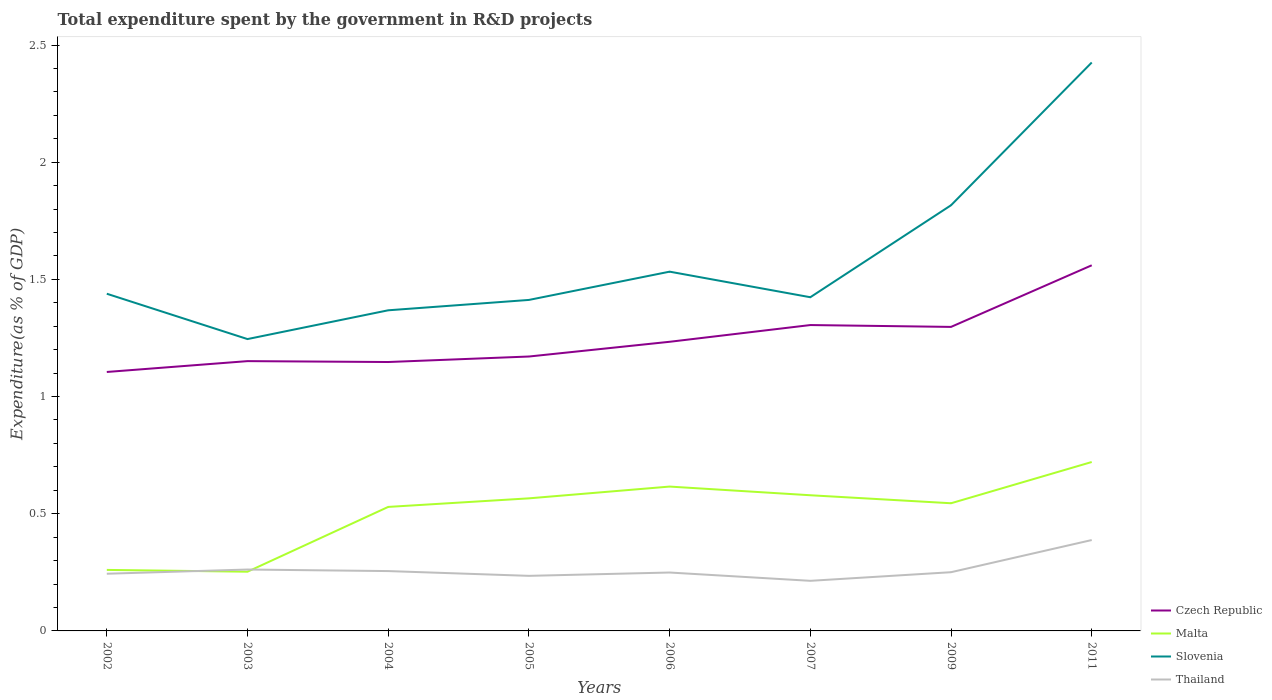How many different coloured lines are there?
Make the answer very short. 4. Does the line corresponding to Malta intersect with the line corresponding to Czech Republic?
Your response must be concise. No. Is the number of lines equal to the number of legend labels?
Your response must be concise. Yes. Across all years, what is the maximum total expenditure spent by the government in R&D projects in Czech Republic?
Provide a succinct answer. 1.1. In which year was the total expenditure spent by the government in R&D projects in Slovenia maximum?
Offer a very short reply. 2003. What is the total total expenditure spent by the government in R&D projects in Thailand in the graph?
Keep it short and to the point. -0.17. What is the difference between the highest and the second highest total expenditure spent by the government in R&D projects in Malta?
Keep it short and to the point. 0.47. Is the total expenditure spent by the government in R&D projects in Thailand strictly greater than the total expenditure spent by the government in R&D projects in Czech Republic over the years?
Your response must be concise. Yes. How many lines are there?
Ensure brevity in your answer.  4. What is the difference between two consecutive major ticks on the Y-axis?
Your answer should be very brief. 0.5. Are the values on the major ticks of Y-axis written in scientific E-notation?
Provide a succinct answer. No. How many legend labels are there?
Provide a short and direct response. 4. How are the legend labels stacked?
Offer a very short reply. Vertical. What is the title of the graph?
Your answer should be compact. Total expenditure spent by the government in R&D projects. What is the label or title of the Y-axis?
Your answer should be compact. Expenditure(as % of GDP). What is the Expenditure(as % of GDP) in Czech Republic in 2002?
Give a very brief answer. 1.1. What is the Expenditure(as % of GDP) in Malta in 2002?
Your answer should be very brief. 0.26. What is the Expenditure(as % of GDP) in Slovenia in 2002?
Provide a succinct answer. 1.44. What is the Expenditure(as % of GDP) of Thailand in 2002?
Offer a very short reply. 0.24. What is the Expenditure(as % of GDP) of Czech Republic in 2003?
Provide a succinct answer. 1.15. What is the Expenditure(as % of GDP) of Malta in 2003?
Provide a succinct answer. 0.25. What is the Expenditure(as % of GDP) in Slovenia in 2003?
Ensure brevity in your answer.  1.25. What is the Expenditure(as % of GDP) in Thailand in 2003?
Your answer should be compact. 0.26. What is the Expenditure(as % of GDP) of Czech Republic in 2004?
Offer a terse response. 1.15. What is the Expenditure(as % of GDP) of Malta in 2004?
Provide a short and direct response. 0.53. What is the Expenditure(as % of GDP) of Slovenia in 2004?
Give a very brief answer. 1.37. What is the Expenditure(as % of GDP) of Thailand in 2004?
Offer a terse response. 0.26. What is the Expenditure(as % of GDP) in Czech Republic in 2005?
Your answer should be compact. 1.17. What is the Expenditure(as % of GDP) in Malta in 2005?
Provide a short and direct response. 0.57. What is the Expenditure(as % of GDP) in Slovenia in 2005?
Keep it short and to the point. 1.41. What is the Expenditure(as % of GDP) in Thailand in 2005?
Your answer should be compact. 0.23. What is the Expenditure(as % of GDP) of Czech Republic in 2006?
Your answer should be very brief. 1.23. What is the Expenditure(as % of GDP) in Malta in 2006?
Keep it short and to the point. 0.62. What is the Expenditure(as % of GDP) of Slovenia in 2006?
Offer a very short reply. 1.53. What is the Expenditure(as % of GDP) in Thailand in 2006?
Offer a terse response. 0.25. What is the Expenditure(as % of GDP) in Czech Republic in 2007?
Make the answer very short. 1.31. What is the Expenditure(as % of GDP) of Malta in 2007?
Provide a short and direct response. 0.58. What is the Expenditure(as % of GDP) of Slovenia in 2007?
Give a very brief answer. 1.42. What is the Expenditure(as % of GDP) of Thailand in 2007?
Keep it short and to the point. 0.21. What is the Expenditure(as % of GDP) of Czech Republic in 2009?
Your answer should be very brief. 1.3. What is the Expenditure(as % of GDP) of Malta in 2009?
Your response must be concise. 0.54. What is the Expenditure(as % of GDP) in Slovenia in 2009?
Keep it short and to the point. 1.82. What is the Expenditure(as % of GDP) of Thailand in 2009?
Provide a short and direct response. 0.25. What is the Expenditure(as % of GDP) in Czech Republic in 2011?
Offer a terse response. 1.56. What is the Expenditure(as % of GDP) of Malta in 2011?
Provide a short and direct response. 0.72. What is the Expenditure(as % of GDP) in Slovenia in 2011?
Your answer should be compact. 2.43. What is the Expenditure(as % of GDP) in Thailand in 2011?
Ensure brevity in your answer.  0.39. Across all years, what is the maximum Expenditure(as % of GDP) of Czech Republic?
Your answer should be very brief. 1.56. Across all years, what is the maximum Expenditure(as % of GDP) in Malta?
Provide a succinct answer. 0.72. Across all years, what is the maximum Expenditure(as % of GDP) of Slovenia?
Your answer should be very brief. 2.43. Across all years, what is the maximum Expenditure(as % of GDP) in Thailand?
Your response must be concise. 0.39. Across all years, what is the minimum Expenditure(as % of GDP) of Czech Republic?
Your response must be concise. 1.1. Across all years, what is the minimum Expenditure(as % of GDP) in Malta?
Ensure brevity in your answer.  0.25. Across all years, what is the minimum Expenditure(as % of GDP) of Slovenia?
Make the answer very short. 1.25. Across all years, what is the minimum Expenditure(as % of GDP) of Thailand?
Keep it short and to the point. 0.21. What is the total Expenditure(as % of GDP) in Czech Republic in the graph?
Provide a short and direct response. 9.97. What is the total Expenditure(as % of GDP) in Malta in the graph?
Give a very brief answer. 4.07. What is the total Expenditure(as % of GDP) of Slovenia in the graph?
Provide a short and direct response. 12.66. What is the total Expenditure(as % of GDP) of Thailand in the graph?
Your answer should be very brief. 2.1. What is the difference between the Expenditure(as % of GDP) of Czech Republic in 2002 and that in 2003?
Offer a very short reply. -0.05. What is the difference between the Expenditure(as % of GDP) in Malta in 2002 and that in 2003?
Provide a succinct answer. 0.01. What is the difference between the Expenditure(as % of GDP) in Slovenia in 2002 and that in 2003?
Ensure brevity in your answer.  0.19. What is the difference between the Expenditure(as % of GDP) in Thailand in 2002 and that in 2003?
Your answer should be very brief. -0.02. What is the difference between the Expenditure(as % of GDP) in Czech Republic in 2002 and that in 2004?
Your response must be concise. -0.04. What is the difference between the Expenditure(as % of GDP) of Malta in 2002 and that in 2004?
Provide a short and direct response. -0.27. What is the difference between the Expenditure(as % of GDP) in Slovenia in 2002 and that in 2004?
Your answer should be compact. 0.07. What is the difference between the Expenditure(as % of GDP) of Thailand in 2002 and that in 2004?
Provide a short and direct response. -0.01. What is the difference between the Expenditure(as % of GDP) of Czech Republic in 2002 and that in 2005?
Offer a terse response. -0.07. What is the difference between the Expenditure(as % of GDP) of Malta in 2002 and that in 2005?
Make the answer very short. -0.31. What is the difference between the Expenditure(as % of GDP) of Slovenia in 2002 and that in 2005?
Your response must be concise. 0.03. What is the difference between the Expenditure(as % of GDP) of Thailand in 2002 and that in 2005?
Offer a very short reply. 0.01. What is the difference between the Expenditure(as % of GDP) of Czech Republic in 2002 and that in 2006?
Keep it short and to the point. -0.13. What is the difference between the Expenditure(as % of GDP) of Malta in 2002 and that in 2006?
Your response must be concise. -0.36. What is the difference between the Expenditure(as % of GDP) of Slovenia in 2002 and that in 2006?
Provide a short and direct response. -0.09. What is the difference between the Expenditure(as % of GDP) in Thailand in 2002 and that in 2006?
Your answer should be compact. -0.01. What is the difference between the Expenditure(as % of GDP) of Czech Republic in 2002 and that in 2007?
Give a very brief answer. -0.2. What is the difference between the Expenditure(as % of GDP) of Malta in 2002 and that in 2007?
Offer a very short reply. -0.32. What is the difference between the Expenditure(as % of GDP) of Slovenia in 2002 and that in 2007?
Make the answer very short. 0.01. What is the difference between the Expenditure(as % of GDP) in Thailand in 2002 and that in 2007?
Offer a terse response. 0.03. What is the difference between the Expenditure(as % of GDP) of Czech Republic in 2002 and that in 2009?
Your answer should be compact. -0.19. What is the difference between the Expenditure(as % of GDP) in Malta in 2002 and that in 2009?
Offer a terse response. -0.28. What is the difference between the Expenditure(as % of GDP) of Slovenia in 2002 and that in 2009?
Your answer should be compact. -0.38. What is the difference between the Expenditure(as % of GDP) of Thailand in 2002 and that in 2009?
Ensure brevity in your answer.  -0.01. What is the difference between the Expenditure(as % of GDP) of Czech Republic in 2002 and that in 2011?
Give a very brief answer. -0.46. What is the difference between the Expenditure(as % of GDP) in Malta in 2002 and that in 2011?
Your answer should be compact. -0.46. What is the difference between the Expenditure(as % of GDP) of Slovenia in 2002 and that in 2011?
Give a very brief answer. -0.99. What is the difference between the Expenditure(as % of GDP) of Thailand in 2002 and that in 2011?
Give a very brief answer. -0.14. What is the difference between the Expenditure(as % of GDP) in Czech Republic in 2003 and that in 2004?
Offer a terse response. 0. What is the difference between the Expenditure(as % of GDP) in Malta in 2003 and that in 2004?
Your answer should be compact. -0.28. What is the difference between the Expenditure(as % of GDP) in Slovenia in 2003 and that in 2004?
Keep it short and to the point. -0.12. What is the difference between the Expenditure(as % of GDP) in Thailand in 2003 and that in 2004?
Provide a succinct answer. 0.01. What is the difference between the Expenditure(as % of GDP) in Czech Republic in 2003 and that in 2005?
Your answer should be compact. -0.02. What is the difference between the Expenditure(as % of GDP) of Malta in 2003 and that in 2005?
Offer a terse response. -0.31. What is the difference between the Expenditure(as % of GDP) in Slovenia in 2003 and that in 2005?
Your answer should be compact. -0.17. What is the difference between the Expenditure(as % of GDP) in Thailand in 2003 and that in 2005?
Offer a very short reply. 0.03. What is the difference between the Expenditure(as % of GDP) of Czech Republic in 2003 and that in 2006?
Provide a succinct answer. -0.08. What is the difference between the Expenditure(as % of GDP) of Malta in 2003 and that in 2006?
Your response must be concise. -0.36. What is the difference between the Expenditure(as % of GDP) in Slovenia in 2003 and that in 2006?
Provide a succinct answer. -0.29. What is the difference between the Expenditure(as % of GDP) of Thailand in 2003 and that in 2006?
Your answer should be very brief. 0.01. What is the difference between the Expenditure(as % of GDP) in Czech Republic in 2003 and that in 2007?
Keep it short and to the point. -0.15. What is the difference between the Expenditure(as % of GDP) in Malta in 2003 and that in 2007?
Make the answer very short. -0.33. What is the difference between the Expenditure(as % of GDP) of Slovenia in 2003 and that in 2007?
Ensure brevity in your answer.  -0.18. What is the difference between the Expenditure(as % of GDP) of Thailand in 2003 and that in 2007?
Keep it short and to the point. 0.05. What is the difference between the Expenditure(as % of GDP) in Czech Republic in 2003 and that in 2009?
Offer a very short reply. -0.15. What is the difference between the Expenditure(as % of GDP) in Malta in 2003 and that in 2009?
Keep it short and to the point. -0.29. What is the difference between the Expenditure(as % of GDP) of Slovenia in 2003 and that in 2009?
Provide a succinct answer. -0.57. What is the difference between the Expenditure(as % of GDP) of Thailand in 2003 and that in 2009?
Your response must be concise. 0.01. What is the difference between the Expenditure(as % of GDP) of Czech Republic in 2003 and that in 2011?
Offer a terse response. -0.41. What is the difference between the Expenditure(as % of GDP) of Malta in 2003 and that in 2011?
Offer a very short reply. -0.47. What is the difference between the Expenditure(as % of GDP) of Slovenia in 2003 and that in 2011?
Ensure brevity in your answer.  -1.18. What is the difference between the Expenditure(as % of GDP) of Thailand in 2003 and that in 2011?
Your response must be concise. -0.13. What is the difference between the Expenditure(as % of GDP) of Czech Republic in 2004 and that in 2005?
Keep it short and to the point. -0.02. What is the difference between the Expenditure(as % of GDP) of Malta in 2004 and that in 2005?
Offer a terse response. -0.04. What is the difference between the Expenditure(as % of GDP) of Slovenia in 2004 and that in 2005?
Your answer should be compact. -0.04. What is the difference between the Expenditure(as % of GDP) in Thailand in 2004 and that in 2005?
Give a very brief answer. 0.02. What is the difference between the Expenditure(as % of GDP) of Czech Republic in 2004 and that in 2006?
Offer a terse response. -0.09. What is the difference between the Expenditure(as % of GDP) in Malta in 2004 and that in 2006?
Your answer should be compact. -0.09. What is the difference between the Expenditure(as % of GDP) in Slovenia in 2004 and that in 2006?
Offer a very short reply. -0.16. What is the difference between the Expenditure(as % of GDP) in Thailand in 2004 and that in 2006?
Your response must be concise. 0.01. What is the difference between the Expenditure(as % of GDP) in Czech Republic in 2004 and that in 2007?
Keep it short and to the point. -0.16. What is the difference between the Expenditure(as % of GDP) of Malta in 2004 and that in 2007?
Keep it short and to the point. -0.05. What is the difference between the Expenditure(as % of GDP) in Slovenia in 2004 and that in 2007?
Give a very brief answer. -0.06. What is the difference between the Expenditure(as % of GDP) in Thailand in 2004 and that in 2007?
Make the answer very short. 0.04. What is the difference between the Expenditure(as % of GDP) of Czech Republic in 2004 and that in 2009?
Give a very brief answer. -0.15. What is the difference between the Expenditure(as % of GDP) of Malta in 2004 and that in 2009?
Your answer should be compact. -0.02. What is the difference between the Expenditure(as % of GDP) in Slovenia in 2004 and that in 2009?
Give a very brief answer. -0.45. What is the difference between the Expenditure(as % of GDP) of Thailand in 2004 and that in 2009?
Keep it short and to the point. 0. What is the difference between the Expenditure(as % of GDP) of Czech Republic in 2004 and that in 2011?
Keep it short and to the point. -0.41. What is the difference between the Expenditure(as % of GDP) of Malta in 2004 and that in 2011?
Offer a terse response. -0.19. What is the difference between the Expenditure(as % of GDP) in Slovenia in 2004 and that in 2011?
Your answer should be compact. -1.06. What is the difference between the Expenditure(as % of GDP) of Thailand in 2004 and that in 2011?
Your answer should be very brief. -0.13. What is the difference between the Expenditure(as % of GDP) of Czech Republic in 2005 and that in 2006?
Make the answer very short. -0.06. What is the difference between the Expenditure(as % of GDP) in Malta in 2005 and that in 2006?
Your answer should be very brief. -0.05. What is the difference between the Expenditure(as % of GDP) in Slovenia in 2005 and that in 2006?
Your answer should be very brief. -0.12. What is the difference between the Expenditure(as % of GDP) in Thailand in 2005 and that in 2006?
Ensure brevity in your answer.  -0.01. What is the difference between the Expenditure(as % of GDP) of Czech Republic in 2005 and that in 2007?
Provide a short and direct response. -0.13. What is the difference between the Expenditure(as % of GDP) of Malta in 2005 and that in 2007?
Your response must be concise. -0.01. What is the difference between the Expenditure(as % of GDP) in Slovenia in 2005 and that in 2007?
Ensure brevity in your answer.  -0.01. What is the difference between the Expenditure(as % of GDP) in Thailand in 2005 and that in 2007?
Your answer should be compact. 0.02. What is the difference between the Expenditure(as % of GDP) of Czech Republic in 2005 and that in 2009?
Keep it short and to the point. -0.13. What is the difference between the Expenditure(as % of GDP) of Malta in 2005 and that in 2009?
Provide a succinct answer. 0.02. What is the difference between the Expenditure(as % of GDP) of Slovenia in 2005 and that in 2009?
Provide a short and direct response. -0.4. What is the difference between the Expenditure(as % of GDP) in Thailand in 2005 and that in 2009?
Your answer should be compact. -0.02. What is the difference between the Expenditure(as % of GDP) of Czech Republic in 2005 and that in 2011?
Ensure brevity in your answer.  -0.39. What is the difference between the Expenditure(as % of GDP) in Malta in 2005 and that in 2011?
Make the answer very short. -0.16. What is the difference between the Expenditure(as % of GDP) of Slovenia in 2005 and that in 2011?
Ensure brevity in your answer.  -1.01. What is the difference between the Expenditure(as % of GDP) in Thailand in 2005 and that in 2011?
Your answer should be compact. -0.15. What is the difference between the Expenditure(as % of GDP) in Czech Republic in 2006 and that in 2007?
Your answer should be compact. -0.07. What is the difference between the Expenditure(as % of GDP) of Malta in 2006 and that in 2007?
Your answer should be very brief. 0.04. What is the difference between the Expenditure(as % of GDP) in Slovenia in 2006 and that in 2007?
Your response must be concise. 0.11. What is the difference between the Expenditure(as % of GDP) in Thailand in 2006 and that in 2007?
Ensure brevity in your answer.  0.04. What is the difference between the Expenditure(as % of GDP) in Czech Republic in 2006 and that in 2009?
Your answer should be very brief. -0.06. What is the difference between the Expenditure(as % of GDP) of Malta in 2006 and that in 2009?
Your response must be concise. 0.07. What is the difference between the Expenditure(as % of GDP) in Slovenia in 2006 and that in 2009?
Your answer should be very brief. -0.28. What is the difference between the Expenditure(as % of GDP) of Thailand in 2006 and that in 2009?
Your answer should be compact. -0. What is the difference between the Expenditure(as % of GDP) in Czech Republic in 2006 and that in 2011?
Offer a very short reply. -0.33. What is the difference between the Expenditure(as % of GDP) of Malta in 2006 and that in 2011?
Your response must be concise. -0.1. What is the difference between the Expenditure(as % of GDP) in Slovenia in 2006 and that in 2011?
Give a very brief answer. -0.89. What is the difference between the Expenditure(as % of GDP) in Thailand in 2006 and that in 2011?
Your response must be concise. -0.14. What is the difference between the Expenditure(as % of GDP) of Czech Republic in 2007 and that in 2009?
Make the answer very short. 0.01. What is the difference between the Expenditure(as % of GDP) of Malta in 2007 and that in 2009?
Ensure brevity in your answer.  0.03. What is the difference between the Expenditure(as % of GDP) of Slovenia in 2007 and that in 2009?
Offer a terse response. -0.39. What is the difference between the Expenditure(as % of GDP) in Thailand in 2007 and that in 2009?
Your answer should be very brief. -0.04. What is the difference between the Expenditure(as % of GDP) of Czech Republic in 2007 and that in 2011?
Your answer should be compact. -0.26. What is the difference between the Expenditure(as % of GDP) of Malta in 2007 and that in 2011?
Ensure brevity in your answer.  -0.14. What is the difference between the Expenditure(as % of GDP) of Slovenia in 2007 and that in 2011?
Your answer should be very brief. -1. What is the difference between the Expenditure(as % of GDP) of Thailand in 2007 and that in 2011?
Ensure brevity in your answer.  -0.17. What is the difference between the Expenditure(as % of GDP) of Czech Republic in 2009 and that in 2011?
Provide a short and direct response. -0.26. What is the difference between the Expenditure(as % of GDP) in Malta in 2009 and that in 2011?
Your response must be concise. -0.18. What is the difference between the Expenditure(as % of GDP) of Slovenia in 2009 and that in 2011?
Keep it short and to the point. -0.61. What is the difference between the Expenditure(as % of GDP) of Thailand in 2009 and that in 2011?
Ensure brevity in your answer.  -0.14. What is the difference between the Expenditure(as % of GDP) in Czech Republic in 2002 and the Expenditure(as % of GDP) in Malta in 2003?
Your response must be concise. 0.85. What is the difference between the Expenditure(as % of GDP) in Czech Republic in 2002 and the Expenditure(as % of GDP) in Slovenia in 2003?
Offer a terse response. -0.14. What is the difference between the Expenditure(as % of GDP) of Czech Republic in 2002 and the Expenditure(as % of GDP) of Thailand in 2003?
Provide a short and direct response. 0.84. What is the difference between the Expenditure(as % of GDP) in Malta in 2002 and the Expenditure(as % of GDP) in Slovenia in 2003?
Make the answer very short. -0.98. What is the difference between the Expenditure(as % of GDP) in Malta in 2002 and the Expenditure(as % of GDP) in Thailand in 2003?
Offer a very short reply. -0. What is the difference between the Expenditure(as % of GDP) of Slovenia in 2002 and the Expenditure(as % of GDP) of Thailand in 2003?
Your answer should be very brief. 1.18. What is the difference between the Expenditure(as % of GDP) of Czech Republic in 2002 and the Expenditure(as % of GDP) of Malta in 2004?
Provide a short and direct response. 0.58. What is the difference between the Expenditure(as % of GDP) in Czech Republic in 2002 and the Expenditure(as % of GDP) in Slovenia in 2004?
Your answer should be compact. -0.26. What is the difference between the Expenditure(as % of GDP) in Czech Republic in 2002 and the Expenditure(as % of GDP) in Thailand in 2004?
Your answer should be compact. 0.85. What is the difference between the Expenditure(as % of GDP) in Malta in 2002 and the Expenditure(as % of GDP) in Slovenia in 2004?
Offer a terse response. -1.11. What is the difference between the Expenditure(as % of GDP) of Malta in 2002 and the Expenditure(as % of GDP) of Thailand in 2004?
Provide a succinct answer. 0.01. What is the difference between the Expenditure(as % of GDP) in Slovenia in 2002 and the Expenditure(as % of GDP) in Thailand in 2004?
Provide a short and direct response. 1.18. What is the difference between the Expenditure(as % of GDP) in Czech Republic in 2002 and the Expenditure(as % of GDP) in Malta in 2005?
Your answer should be compact. 0.54. What is the difference between the Expenditure(as % of GDP) in Czech Republic in 2002 and the Expenditure(as % of GDP) in Slovenia in 2005?
Offer a very short reply. -0.31. What is the difference between the Expenditure(as % of GDP) in Czech Republic in 2002 and the Expenditure(as % of GDP) in Thailand in 2005?
Provide a short and direct response. 0.87. What is the difference between the Expenditure(as % of GDP) of Malta in 2002 and the Expenditure(as % of GDP) of Slovenia in 2005?
Give a very brief answer. -1.15. What is the difference between the Expenditure(as % of GDP) of Malta in 2002 and the Expenditure(as % of GDP) of Thailand in 2005?
Make the answer very short. 0.03. What is the difference between the Expenditure(as % of GDP) of Slovenia in 2002 and the Expenditure(as % of GDP) of Thailand in 2005?
Your answer should be very brief. 1.2. What is the difference between the Expenditure(as % of GDP) of Czech Republic in 2002 and the Expenditure(as % of GDP) of Malta in 2006?
Offer a terse response. 0.49. What is the difference between the Expenditure(as % of GDP) of Czech Republic in 2002 and the Expenditure(as % of GDP) of Slovenia in 2006?
Your answer should be compact. -0.43. What is the difference between the Expenditure(as % of GDP) in Czech Republic in 2002 and the Expenditure(as % of GDP) in Thailand in 2006?
Make the answer very short. 0.86. What is the difference between the Expenditure(as % of GDP) in Malta in 2002 and the Expenditure(as % of GDP) in Slovenia in 2006?
Provide a short and direct response. -1.27. What is the difference between the Expenditure(as % of GDP) in Malta in 2002 and the Expenditure(as % of GDP) in Thailand in 2006?
Make the answer very short. 0.01. What is the difference between the Expenditure(as % of GDP) of Slovenia in 2002 and the Expenditure(as % of GDP) of Thailand in 2006?
Your response must be concise. 1.19. What is the difference between the Expenditure(as % of GDP) of Czech Republic in 2002 and the Expenditure(as % of GDP) of Malta in 2007?
Your response must be concise. 0.53. What is the difference between the Expenditure(as % of GDP) of Czech Republic in 2002 and the Expenditure(as % of GDP) of Slovenia in 2007?
Offer a terse response. -0.32. What is the difference between the Expenditure(as % of GDP) of Czech Republic in 2002 and the Expenditure(as % of GDP) of Thailand in 2007?
Keep it short and to the point. 0.89. What is the difference between the Expenditure(as % of GDP) of Malta in 2002 and the Expenditure(as % of GDP) of Slovenia in 2007?
Ensure brevity in your answer.  -1.16. What is the difference between the Expenditure(as % of GDP) of Malta in 2002 and the Expenditure(as % of GDP) of Thailand in 2007?
Your answer should be very brief. 0.05. What is the difference between the Expenditure(as % of GDP) in Slovenia in 2002 and the Expenditure(as % of GDP) in Thailand in 2007?
Ensure brevity in your answer.  1.23. What is the difference between the Expenditure(as % of GDP) in Czech Republic in 2002 and the Expenditure(as % of GDP) in Malta in 2009?
Offer a terse response. 0.56. What is the difference between the Expenditure(as % of GDP) in Czech Republic in 2002 and the Expenditure(as % of GDP) in Slovenia in 2009?
Your response must be concise. -0.71. What is the difference between the Expenditure(as % of GDP) in Czech Republic in 2002 and the Expenditure(as % of GDP) in Thailand in 2009?
Keep it short and to the point. 0.85. What is the difference between the Expenditure(as % of GDP) in Malta in 2002 and the Expenditure(as % of GDP) in Slovenia in 2009?
Ensure brevity in your answer.  -1.56. What is the difference between the Expenditure(as % of GDP) of Malta in 2002 and the Expenditure(as % of GDP) of Thailand in 2009?
Your response must be concise. 0.01. What is the difference between the Expenditure(as % of GDP) of Slovenia in 2002 and the Expenditure(as % of GDP) of Thailand in 2009?
Make the answer very short. 1.19. What is the difference between the Expenditure(as % of GDP) of Czech Republic in 2002 and the Expenditure(as % of GDP) of Malta in 2011?
Keep it short and to the point. 0.38. What is the difference between the Expenditure(as % of GDP) in Czech Republic in 2002 and the Expenditure(as % of GDP) in Slovenia in 2011?
Your answer should be compact. -1.32. What is the difference between the Expenditure(as % of GDP) of Czech Republic in 2002 and the Expenditure(as % of GDP) of Thailand in 2011?
Your answer should be compact. 0.72. What is the difference between the Expenditure(as % of GDP) in Malta in 2002 and the Expenditure(as % of GDP) in Slovenia in 2011?
Your answer should be compact. -2.17. What is the difference between the Expenditure(as % of GDP) in Malta in 2002 and the Expenditure(as % of GDP) in Thailand in 2011?
Provide a succinct answer. -0.13. What is the difference between the Expenditure(as % of GDP) of Slovenia in 2002 and the Expenditure(as % of GDP) of Thailand in 2011?
Make the answer very short. 1.05. What is the difference between the Expenditure(as % of GDP) in Czech Republic in 2003 and the Expenditure(as % of GDP) in Malta in 2004?
Provide a short and direct response. 0.62. What is the difference between the Expenditure(as % of GDP) of Czech Republic in 2003 and the Expenditure(as % of GDP) of Slovenia in 2004?
Your answer should be compact. -0.22. What is the difference between the Expenditure(as % of GDP) of Czech Republic in 2003 and the Expenditure(as % of GDP) of Thailand in 2004?
Ensure brevity in your answer.  0.9. What is the difference between the Expenditure(as % of GDP) in Malta in 2003 and the Expenditure(as % of GDP) in Slovenia in 2004?
Offer a very short reply. -1.12. What is the difference between the Expenditure(as % of GDP) of Malta in 2003 and the Expenditure(as % of GDP) of Thailand in 2004?
Your answer should be very brief. -0. What is the difference between the Expenditure(as % of GDP) of Slovenia in 2003 and the Expenditure(as % of GDP) of Thailand in 2004?
Make the answer very short. 0.99. What is the difference between the Expenditure(as % of GDP) in Czech Republic in 2003 and the Expenditure(as % of GDP) in Malta in 2005?
Provide a short and direct response. 0.59. What is the difference between the Expenditure(as % of GDP) in Czech Republic in 2003 and the Expenditure(as % of GDP) in Slovenia in 2005?
Offer a terse response. -0.26. What is the difference between the Expenditure(as % of GDP) in Czech Republic in 2003 and the Expenditure(as % of GDP) in Thailand in 2005?
Offer a terse response. 0.92. What is the difference between the Expenditure(as % of GDP) in Malta in 2003 and the Expenditure(as % of GDP) in Slovenia in 2005?
Your answer should be very brief. -1.16. What is the difference between the Expenditure(as % of GDP) of Malta in 2003 and the Expenditure(as % of GDP) of Thailand in 2005?
Your answer should be compact. 0.02. What is the difference between the Expenditure(as % of GDP) of Slovenia in 2003 and the Expenditure(as % of GDP) of Thailand in 2005?
Keep it short and to the point. 1.01. What is the difference between the Expenditure(as % of GDP) in Czech Republic in 2003 and the Expenditure(as % of GDP) in Malta in 2006?
Your answer should be compact. 0.54. What is the difference between the Expenditure(as % of GDP) in Czech Republic in 2003 and the Expenditure(as % of GDP) in Slovenia in 2006?
Provide a short and direct response. -0.38. What is the difference between the Expenditure(as % of GDP) in Czech Republic in 2003 and the Expenditure(as % of GDP) in Thailand in 2006?
Your response must be concise. 0.9. What is the difference between the Expenditure(as % of GDP) of Malta in 2003 and the Expenditure(as % of GDP) of Slovenia in 2006?
Make the answer very short. -1.28. What is the difference between the Expenditure(as % of GDP) of Malta in 2003 and the Expenditure(as % of GDP) of Thailand in 2006?
Provide a short and direct response. 0. What is the difference between the Expenditure(as % of GDP) of Czech Republic in 2003 and the Expenditure(as % of GDP) of Malta in 2007?
Provide a succinct answer. 0.57. What is the difference between the Expenditure(as % of GDP) of Czech Republic in 2003 and the Expenditure(as % of GDP) of Slovenia in 2007?
Your answer should be compact. -0.27. What is the difference between the Expenditure(as % of GDP) in Czech Republic in 2003 and the Expenditure(as % of GDP) in Thailand in 2007?
Offer a terse response. 0.94. What is the difference between the Expenditure(as % of GDP) in Malta in 2003 and the Expenditure(as % of GDP) in Slovenia in 2007?
Keep it short and to the point. -1.17. What is the difference between the Expenditure(as % of GDP) in Malta in 2003 and the Expenditure(as % of GDP) in Thailand in 2007?
Your answer should be very brief. 0.04. What is the difference between the Expenditure(as % of GDP) in Slovenia in 2003 and the Expenditure(as % of GDP) in Thailand in 2007?
Your response must be concise. 1.03. What is the difference between the Expenditure(as % of GDP) in Czech Republic in 2003 and the Expenditure(as % of GDP) in Malta in 2009?
Your answer should be compact. 0.61. What is the difference between the Expenditure(as % of GDP) of Czech Republic in 2003 and the Expenditure(as % of GDP) of Slovenia in 2009?
Ensure brevity in your answer.  -0.67. What is the difference between the Expenditure(as % of GDP) in Czech Republic in 2003 and the Expenditure(as % of GDP) in Thailand in 2009?
Your answer should be compact. 0.9. What is the difference between the Expenditure(as % of GDP) in Malta in 2003 and the Expenditure(as % of GDP) in Slovenia in 2009?
Give a very brief answer. -1.56. What is the difference between the Expenditure(as % of GDP) in Malta in 2003 and the Expenditure(as % of GDP) in Thailand in 2009?
Provide a succinct answer. 0. What is the difference between the Expenditure(as % of GDP) in Slovenia in 2003 and the Expenditure(as % of GDP) in Thailand in 2009?
Keep it short and to the point. 0.99. What is the difference between the Expenditure(as % of GDP) of Czech Republic in 2003 and the Expenditure(as % of GDP) of Malta in 2011?
Provide a short and direct response. 0.43. What is the difference between the Expenditure(as % of GDP) in Czech Republic in 2003 and the Expenditure(as % of GDP) in Slovenia in 2011?
Provide a succinct answer. -1.27. What is the difference between the Expenditure(as % of GDP) of Czech Republic in 2003 and the Expenditure(as % of GDP) of Thailand in 2011?
Your answer should be very brief. 0.76. What is the difference between the Expenditure(as % of GDP) in Malta in 2003 and the Expenditure(as % of GDP) in Slovenia in 2011?
Offer a very short reply. -2.17. What is the difference between the Expenditure(as % of GDP) in Malta in 2003 and the Expenditure(as % of GDP) in Thailand in 2011?
Your response must be concise. -0.14. What is the difference between the Expenditure(as % of GDP) of Slovenia in 2003 and the Expenditure(as % of GDP) of Thailand in 2011?
Your response must be concise. 0.86. What is the difference between the Expenditure(as % of GDP) of Czech Republic in 2004 and the Expenditure(as % of GDP) of Malta in 2005?
Provide a short and direct response. 0.58. What is the difference between the Expenditure(as % of GDP) of Czech Republic in 2004 and the Expenditure(as % of GDP) of Slovenia in 2005?
Your response must be concise. -0.26. What is the difference between the Expenditure(as % of GDP) in Czech Republic in 2004 and the Expenditure(as % of GDP) in Thailand in 2005?
Keep it short and to the point. 0.91. What is the difference between the Expenditure(as % of GDP) of Malta in 2004 and the Expenditure(as % of GDP) of Slovenia in 2005?
Your answer should be compact. -0.88. What is the difference between the Expenditure(as % of GDP) in Malta in 2004 and the Expenditure(as % of GDP) in Thailand in 2005?
Keep it short and to the point. 0.29. What is the difference between the Expenditure(as % of GDP) of Slovenia in 2004 and the Expenditure(as % of GDP) of Thailand in 2005?
Keep it short and to the point. 1.13. What is the difference between the Expenditure(as % of GDP) in Czech Republic in 2004 and the Expenditure(as % of GDP) in Malta in 2006?
Ensure brevity in your answer.  0.53. What is the difference between the Expenditure(as % of GDP) in Czech Republic in 2004 and the Expenditure(as % of GDP) in Slovenia in 2006?
Provide a short and direct response. -0.39. What is the difference between the Expenditure(as % of GDP) in Czech Republic in 2004 and the Expenditure(as % of GDP) in Thailand in 2006?
Your answer should be compact. 0.9. What is the difference between the Expenditure(as % of GDP) of Malta in 2004 and the Expenditure(as % of GDP) of Slovenia in 2006?
Your answer should be compact. -1. What is the difference between the Expenditure(as % of GDP) of Malta in 2004 and the Expenditure(as % of GDP) of Thailand in 2006?
Give a very brief answer. 0.28. What is the difference between the Expenditure(as % of GDP) in Slovenia in 2004 and the Expenditure(as % of GDP) in Thailand in 2006?
Your answer should be compact. 1.12. What is the difference between the Expenditure(as % of GDP) of Czech Republic in 2004 and the Expenditure(as % of GDP) of Malta in 2007?
Offer a terse response. 0.57. What is the difference between the Expenditure(as % of GDP) of Czech Republic in 2004 and the Expenditure(as % of GDP) of Slovenia in 2007?
Your answer should be very brief. -0.28. What is the difference between the Expenditure(as % of GDP) of Czech Republic in 2004 and the Expenditure(as % of GDP) of Thailand in 2007?
Your answer should be very brief. 0.93. What is the difference between the Expenditure(as % of GDP) of Malta in 2004 and the Expenditure(as % of GDP) of Slovenia in 2007?
Your response must be concise. -0.89. What is the difference between the Expenditure(as % of GDP) in Malta in 2004 and the Expenditure(as % of GDP) in Thailand in 2007?
Your response must be concise. 0.32. What is the difference between the Expenditure(as % of GDP) of Slovenia in 2004 and the Expenditure(as % of GDP) of Thailand in 2007?
Keep it short and to the point. 1.15. What is the difference between the Expenditure(as % of GDP) of Czech Republic in 2004 and the Expenditure(as % of GDP) of Malta in 2009?
Offer a terse response. 0.6. What is the difference between the Expenditure(as % of GDP) of Czech Republic in 2004 and the Expenditure(as % of GDP) of Slovenia in 2009?
Make the answer very short. -0.67. What is the difference between the Expenditure(as % of GDP) of Czech Republic in 2004 and the Expenditure(as % of GDP) of Thailand in 2009?
Offer a very short reply. 0.9. What is the difference between the Expenditure(as % of GDP) of Malta in 2004 and the Expenditure(as % of GDP) of Slovenia in 2009?
Your response must be concise. -1.29. What is the difference between the Expenditure(as % of GDP) of Malta in 2004 and the Expenditure(as % of GDP) of Thailand in 2009?
Ensure brevity in your answer.  0.28. What is the difference between the Expenditure(as % of GDP) in Slovenia in 2004 and the Expenditure(as % of GDP) in Thailand in 2009?
Ensure brevity in your answer.  1.12. What is the difference between the Expenditure(as % of GDP) in Czech Republic in 2004 and the Expenditure(as % of GDP) in Malta in 2011?
Give a very brief answer. 0.43. What is the difference between the Expenditure(as % of GDP) of Czech Republic in 2004 and the Expenditure(as % of GDP) of Slovenia in 2011?
Make the answer very short. -1.28. What is the difference between the Expenditure(as % of GDP) in Czech Republic in 2004 and the Expenditure(as % of GDP) in Thailand in 2011?
Your answer should be compact. 0.76. What is the difference between the Expenditure(as % of GDP) of Malta in 2004 and the Expenditure(as % of GDP) of Slovenia in 2011?
Offer a terse response. -1.9. What is the difference between the Expenditure(as % of GDP) in Malta in 2004 and the Expenditure(as % of GDP) in Thailand in 2011?
Make the answer very short. 0.14. What is the difference between the Expenditure(as % of GDP) in Slovenia in 2004 and the Expenditure(as % of GDP) in Thailand in 2011?
Give a very brief answer. 0.98. What is the difference between the Expenditure(as % of GDP) of Czech Republic in 2005 and the Expenditure(as % of GDP) of Malta in 2006?
Your answer should be very brief. 0.55. What is the difference between the Expenditure(as % of GDP) in Czech Republic in 2005 and the Expenditure(as % of GDP) in Slovenia in 2006?
Offer a very short reply. -0.36. What is the difference between the Expenditure(as % of GDP) in Czech Republic in 2005 and the Expenditure(as % of GDP) in Thailand in 2006?
Make the answer very short. 0.92. What is the difference between the Expenditure(as % of GDP) in Malta in 2005 and the Expenditure(as % of GDP) in Slovenia in 2006?
Keep it short and to the point. -0.97. What is the difference between the Expenditure(as % of GDP) of Malta in 2005 and the Expenditure(as % of GDP) of Thailand in 2006?
Ensure brevity in your answer.  0.32. What is the difference between the Expenditure(as % of GDP) of Slovenia in 2005 and the Expenditure(as % of GDP) of Thailand in 2006?
Ensure brevity in your answer.  1.16. What is the difference between the Expenditure(as % of GDP) of Czech Republic in 2005 and the Expenditure(as % of GDP) of Malta in 2007?
Offer a very short reply. 0.59. What is the difference between the Expenditure(as % of GDP) in Czech Republic in 2005 and the Expenditure(as % of GDP) in Slovenia in 2007?
Offer a terse response. -0.25. What is the difference between the Expenditure(as % of GDP) of Czech Republic in 2005 and the Expenditure(as % of GDP) of Thailand in 2007?
Your response must be concise. 0.96. What is the difference between the Expenditure(as % of GDP) of Malta in 2005 and the Expenditure(as % of GDP) of Slovenia in 2007?
Your answer should be very brief. -0.86. What is the difference between the Expenditure(as % of GDP) of Malta in 2005 and the Expenditure(as % of GDP) of Thailand in 2007?
Provide a short and direct response. 0.35. What is the difference between the Expenditure(as % of GDP) in Slovenia in 2005 and the Expenditure(as % of GDP) in Thailand in 2007?
Make the answer very short. 1.2. What is the difference between the Expenditure(as % of GDP) in Czech Republic in 2005 and the Expenditure(as % of GDP) in Malta in 2009?
Your response must be concise. 0.63. What is the difference between the Expenditure(as % of GDP) in Czech Republic in 2005 and the Expenditure(as % of GDP) in Slovenia in 2009?
Your answer should be compact. -0.65. What is the difference between the Expenditure(as % of GDP) of Czech Republic in 2005 and the Expenditure(as % of GDP) of Thailand in 2009?
Your answer should be very brief. 0.92. What is the difference between the Expenditure(as % of GDP) in Malta in 2005 and the Expenditure(as % of GDP) in Slovenia in 2009?
Give a very brief answer. -1.25. What is the difference between the Expenditure(as % of GDP) of Malta in 2005 and the Expenditure(as % of GDP) of Thailand in 2009?
Give a very brief answer. 0.32. What is the difference between the Expenditure(as % of GDP) in Slovenia in 2005 and the Expenditure(as % of GDP) in Thailand in 2009?
Your response must be concise. 1.16. What is the difference between the Expenditure(as % of GDP) in Czech Republic in 2005 and the Expenditure(as % of GDP) in Malta in 2011?
Your response must be concise. 0.45. What is the difference between the Expenditure(as % of GDP) of Czech Republic in 2005 and the Expenditure(as % of GDP) of Slovenia in 2011?
Ensure brevity in your answer.  -1.25. What is the difference between the Expenditure(as % of GDP) in Czech Republic in 2005 and the Expenditure(as % of GDP) in Thailand in 2011?
Offer a very short reply. 0.78. What is the difference between the Expenditure(as % of GDP) in Malta in 2005 and the Expenditure(as % of GDP) in Slovenia in 2011?
Keep it short and to the point. -1.86. What is the difference between the Expenditure(as % of GDP) in Malta in 2005 and the Expenditure(as % of GDP) in Thailand in 2011?
Your answer should be very brief. 0.18. What is the difference between the Expenditure(as % of GDP) of Slovenia in 2005 and the Expenditure(as % of GDP) of Thailand in 2011?
Provide a succinct answer. 1.02. What is the difference between the Expenditure(as % of GDP) of Czech Republic in 2006 and the Expenditure(as % of GDP) of Malta in 2007?
Keep it short and to the point. 0.65. What is the difference between the Expenditure(as % of GDP) in Czech Republic in 2006 and the Expenditure(as % of GDP) in Slovenia in 2007?
Your answer should be compact. -0.19. What is the difference between the Expenditure(as % of GDP) in Czech Republic in 2006 and the Expenditure(as % of GDP) in Thailand in 2007?
Your answer should be compact. 1.02. What is the difference between the Expenditure(as % of GDP) in Malta in 2006 and the Expenditure(as % of GDP) in Slovenia in 2007?
Provide a succinct answer. -0.81. What is the difference between the Expenditure(as % of GDP) in Malta in 2006 and the Expenditure(as % of GDP) in Thailand in 2007?
Provide a succinct answer. 0.4. What is the difference between the Expenditure(as % of GDP) of Slovenia in 2006 and the Expenditure(as % of GDP) of Thailand in 2007?
Offer a very short reply. 1.32. What is the difference between the Expenditure(as % of GDP) in Czech Republic in 2006 and the Expenditure(as % of GDP) in Malta in 2009?
Your answer should be compact. 0.69. What is the difference between the Expenditure(as % of GDP) of Czech Republic in 2006 and the Expenditure(as % of GDP) of Slovenia in 2009?
Your answer should be very brief. -0.58. What is the difference between the Expenditure(as % of GDP) of Czech Republic in 2006 and the Expenditure(as % of GDP) of Thailand in 2009?
Your answer should be compact. 0.98. What is the difference between the Expenditure(as % of GDP) in Malta in 2006 and the Expenditure(as % of GDP) in Slovenia in 2009?
Your answer should be compact. -1.2. What is the difference between the Expenditure(as % of GDP) of Malta in 2006 and the Expenditure(as % of GDP) of Thailand in 2009?
Your answer should be very brief. 0.37. What is the difference between the Expenditure(as % of GDP) of Slovenia in 2006 and the Expenditure(as % of GDP) of Thailand in 2009?
Give a very brief answer. 1.28. What is the difference between the Expenditure(as % of GDP) in Czech Republic in 2006 and the Expenditure(as % of GDP) in Malta in 2011?
Offer a very short reply. 0.51. What is the difference between the Expenditure(as % of GDP) of Czech Republic in 2006 and the Expenditure(as % of GDP) of Slovenia in 2011?
Make the answer very short. -1.19. What is the difference between the Expenditure(as % of GDP) in Czech Republic in 2006 and the Expenditure(as % of GDP) in Thailand in 2011?
Keep it short and to the point. 0.85. What is the difference between the Expenditure(as % of GDP) of Malta in 2006 and the Expenditure(as % of GDP) of Slovenia in 2011?
Make the answer very short. -1.81. What is the difference between the Expenditure(as % of GDP) in Malta in 2006 and the Expenditure(as % of GDP) in Thailand in 2011?
Offer a terse response. 0.23. What is the difference between the Expenditure(as % of GDP) in Slovenia in 2006 and the Expenditure(as % of GDP) in Thailand in 2011?
Make the answer very short. 1.15. What is the difference between the Expenditure(as % of GDP) of Czech Republic in 2007 and the Expenditure(as % of GDP) of Malta in 2009?
Offer a terse response. 0.76. What is the difference between the Expenditure(as % of GDP) of Czech Republic in 2007 and the Expenditure(as % of GDP) of Slovenia in 2009?
Offer a terse response. -0.51. What is the difference between the Expenditure(as % of GDP) in Czech Republic in 2007 and the Expenditure(as % of GDP) in Thailand in 2009?
Your answer should be very brief. 1.05. What is the difference between the Expenditure(as % of GDP) in Malta in 2007 and the Expenditure(as % of GDP) in Slovenia in 2009?
Your answer should be compact. -1.24. What is the difference between the Expenditure(as % of GDP) of Malta in 2007 and the Expenditure(as % of GDP) of Thailand in 2009?
Give a very brief answer. 0.33. What is the difference between the Expenditure(as % of GDP) in Slovenia in 2007 and the Expenditure(as % of GDP) in Thailand in 2009?
Give a very brief answer. 1.17. What is the difference between the Expenditure(as % of GDP) of Czech Republic in 2007 and the Expenditure(as % of GDP) of Malta in 2011?
Ensure brevity in your answer.  0.58. What is the difference between the Expenditure(as % of GDP) in Czech Republic in 2007 and the Expenditure(as % of GDP) in Slovenia in 2011?
Your response must be concise. -1.12. What is the difference between the Expenditure(as % of GDP) in Czech Republic in 2007 and the Expenditure(as % of GDP) in Thailand in 2011?
Offer a very short reply. 0.92. What is the difference between the Expenditure(as % of GDP) in Malta in 2007 and the Expenditure(as % of GDP) in Slovenia in 2011?
Make the answer very short. -1.85. What is the difference between the Expenditure(as % of GDP) of Malta in 2007 and the Expenditure(as % of GDP) of Thailand in 2011?
Offer a terse response. 0.19. What is the difference between the Expenditure(as % of GDP) in Slovenia in 2007 and the Expenditure(as % of GDP) in Thailand in 2011?
Ensure brevity in your answer.  1.04. What is the difference between the Expenditure(as % of GDP) in Czech Republic in 2009 and the Expenditure(as % of GDP) in Malta in 2011?
Ensure brevity in your answer.  0.58. What is the difference between the Expenditure(as % of GDP) of Czech Republic in 2009 and the Expenditure(as % of GDP) of Slovenia in 2011?
Your answer should be compact. -1.13. What is the difference between the Expenditure(as % of GDP) in Czech Republic in 2009 and the Expenditure(as % of GDP) in Thailand in 2011?
Offer a very short reply. 0.91. What is the difference between the Expenditure(as % of GDP) of Malta in 2009 and the Expenditure(as % of GDP) of Slovenia in 2011?
Keep it short and to the point. -1.88. What is the difference between the Expenditure(as % of GDP) in Malta in 2009 and the Expenditure(as % of GDP) in Thailand in 2011?
Provide a succinct answer. 0.16. What is the difference between the Expenditure(as % of GDP) in Slovenia in 2009 and the Expenditure(as % of GDP) in Thailand in 2011?
Provide a succinct answer. 1.43. What is the average Expenditure(as % of GDP) of Czech Republic per year?
Ensure brevity in your answer.  1.25. What is the average Expenditure(as % of GDP) in Malta per year?
Offer a terse response. 0.51. What is the average Expenditure(as % of GDP) of Slovenia per year?
Your response must be concise. 1.58. What is the average Expenditure(as % of GDP) in Thailand per year?
Your response must be concise. 0.26. In the year 2002, what is the difference between the Expenditure(as % of GDP) of Czech Republic and Expenditure(as % of GDP) of Malta?
Ensure brevity in your answer.  0.84. In the year 2002, what is the difference between the Expenditure(as % of GDP) of Czech Republic and Expenditure(as % of GDP) of Slovenia?
Offer a very short reply. -0.33. In the year 2002, what is the difference between the Expenditure(as % of GDP) of Czech Republic and Expenditure(as % of GDP) of Thailand?
Provide a succinct answer. 0.86. In the year 2002, what is the difference between the Expenditure(as % of GDP) in Malta and Expenditure(as % of GDP) in Slovenia?
Provide a succinct answer. -1.18. In the year 2002, what is the difference between the Expenditure(as % of GDP) in Malta and Expenditure(as % of GDP) in Thailand?
Your answer should be compact. 0.02. In the year 2002, what is the difference between the Expenditure(as % of GDP) in Slovenia and Expenditure(as % of GDP) in Thailand?
Make the answer very short. 1.19. In the year 2003, what is the difference between the Expenditure(as % of GDP) in Czech Republic and Expenditure(as % of GDP) in Malta?
Ensure brevity in your answer.  0.9. In the year 2003, what is the difference between the Expenditure(as % of GDP) in Czech Republic and Expenditure(as % of GDP) in Slovenia?
Provide a short and direct response. -0.09. In the year 2003, what is the difference between the Expenditure(as % of GDP) in Czech Republic and Expenditure(as % of GDP) in Thailand?
Keep it short and to the point. 0.89. In the year 2003, what is the difference between the Expenditure(as % of GDP) of Malta and Expenditure(as % of GDP) of Slovenia?
Your response must be concise. -0.99. In the year 2003, what is the difference between the Expenditure(as % of GDP) in Malta and Expenditure(as % of GDP) in Thailand?
Offer a very short reply. -0.01. In the year 2003, what is the difference between the Expenditure(as % of GDP) of Slovenia and Expenditure(as % of GDP) of Thailand?
Your answer should be very brief. 0.98. In the year 2004, what is the difference between the Expenditure(as % of GDP) of Czech Republic and Expenditure(as % of GDP) of Malta?
Your response must be concise. 0.62. In the year 2004, what is the difference between the Expenditure(as % of GDP) of Czech Republic and Expenditure(as % of GDP) of Slovenia?
Make the answer very short. -0.22. In the year 2004, what is the difference between the Expenditure(as % of GDP) in Czech Republic and Expenditure(as % of GDP) in Thailand?
Your answer should be compact. 0.89. In the year 2004, what is the difference between the Expenditure(as % of GDP) in Malta and Expenditure(as % of GDP) in Slovenia?
Give a very brief answer. -0.84. In the year 2004, what is the difference between the Expenditure(as % of GDP) of Malta and Expenditure(as % of GDP) of Thailand?
Give a very brief answer. 0.27. In the year 2004, what is the difference between the Expenditure(as % of GDP) of Slovenia and Expenditure(as % of GDP) of Thailand?
Ensure brevity in your answer.  1.11. In the year 2005, what is the difference between the Expenditure(as % of GDP) of Czech Republic and Expenditure(as % of GDP) of Malta?
Your answer should be very brief. 0.61. In the year 2005, what is the difference between the Expenditure(as % of GDP) of Czech Republic and Expenditure(as % of GDP) of Slovenia?
Make the answer very short. -0.24. In the year 2005, what is the difference between the Expenditure(as % of GDP) of Czech Republic and Expenditure(as % of GDP) of Thailand?
Keep it short and to the point. 0.94. In the year 2005, what is the difference between the Expenditure(as % of GDP) of Malta and Expenditure(as % of GDP) of Slovenia?
Provide a short and direct response. -0.85. In the year 2005, what is the difference between the Expenditure(as % of GDP) in Malta and Expenditure(as % of GDP) in Thailand?
Your answer should be compact. 0.33. In the year 2005, what is the difference between the Expenditure(as % of GDP) of Slovenia and Expenditure(as % of GDP) of Thailand?
Make the answer very short. 1.18. In the year 2006, what is the difference between the Expenditure(as % of GDP) of Czech Republic and Expenditure(as % of GDP) of Malta?
Your response must be concise. 0.62. In the year 2006, what is the difference between the Expenditure(as % of GDP) in Czech Republic and Expenditure(as % of GDP) in Slovenia?
Your answer should be very brief. -0.3. In the year 2006, what is the difference between the Expenditure(as % of GDP) of Czech Republic and Expenditure(as % of GDP) of Thailand?
Your answer should be compact. 0.98. In the year 2006, what is the difference between the Expenditure(as % of GDP) in Malta and Expenditure(as % of GDP) in Slovenia?
Your answer should be very brief. -0.92. In the year 2006, what is the difference between the Expenditure(as % of GDP) of Malta and Expenditure(as % of GDP) of Thailand?
Offer a very short reply. 0.37. In the year 2006, what is the difference between the Expenditure(as % of GDP) in Slovenia and Expenditure(as % of GDP) in Thailand?
Your answer should be very brief. 1.28. In the year 2007, what is the difference between the Expenditure(as % of GDP) of Czech Republic and Expenditure(as % of GDP) of Malta?
Ensure brevity in your answer.  0.73. In the year 2007, what is the difference between the Expenditure(as % of GDP) of Czech Republic and Expenditure(as % of GDP) of Slovenia?
Your answer should be compact. -0.12. In the year 2007, what is the difference between the Expenditure(as % of GDP) of Czech Republic and Expenditure(as % of GDP) of Thailand?
Keep it short and to the point. 1.09. In the year 2007, what is the difference between the Expenditure(as % of GDP) of Malta and Expenditure(as % of GDP) of Slovenia?
Provide a short and direct response. -0.84. In the year 2007, what is the difference between the Expenditure(as % of GDP) of Malta and Expenditure(as % of GDP) of Thailand?
Your answer should be compact. 0.37. In the year 2007, what is the difference between the Expenditure(as % of GDP) of Slovenia and Expenditure(as % of GDP) of Thailand?
Offer a terse response. 1.21. In the year 2009, what is the difference between the Expenditure(as % of GDP) in Czech Republic and Expenditure(as % of GDP) in Malta?
Ensure brevity in your answer.  0.75. In the year 2009, what is the difference between the Expenditure(as % of GDP) of Czech Republic and Expenditure(as % of GDP) of Slovenia?
Your response must be concise. -0.52. In the year 2009, what is the difference between the Expenditure(as % of GDP) in Czech Republic and Expenditure(as % of GDP) in Thailand?
Your response must be concise. 1.05. In the year 2009, what is the difference between the Expenditure(as % of GDP) of Malta and Expenditure(as % of GDP) of Slovenia?
Provide a succinct answer. -1.27. In the year 2009, what is the difference between the Expenditure(as % of GDP) in Malta and Expenditure(as % of GDP) in Thailand?
Your answer should be very brief. 0.29. In the year 2009, what is the difference between the Expenditure(as % of GDP) of Slovenia and Expenditure(as % of GDP) of Thailand?
Keep it short and to the point. 1.57. In the year 2011, what is the difference between the Expenditure(as % of GDP) in Czech Republic and Expenditure(as % of GDP) in Malta?
Your answer should be very brief. 0.84. In the year 2011, what is the difference between the Expenditure(as % of GDP) in Czech Republic and Expenditure(as % of GDP) in Slovenia?
Your response must be concise. -0.87. In the year 2011, what is the difference between the Expenditure(as % of GDP) in Czech Republic and Expenditure(as % of GDP) in Thailand?
Your response must be concise. 1.17. In the year 2011, what is the difference between the Expenditure(as % of GDP) of Malta and Expenditure(as % of GDP) of Slovenia?
Your response must be concise. -1.7. In the year 2011, what is the difference between the Expenditure(as % of GDP) of Malta and Expenditure(as % of GDP) of Thailand?
Your response must be concise. 0.33. In the year 2011, what is the difference between the Expenditure(as % of GDP) of Slovenia and Expenditure(as % of GDP) of Thailand?
Give a very brief answer. 2.04. What is the ratio of the Expenditure(as % of GDP) in Czech Republic in 2002 to that in 2003?
Offer a very short reply. 0.96. What is the ratio of the Expenditure(as % of GDP) in Malta in 2002 to that in 2003?
Provide a short and direct response. 1.03. What is the ratio of the Expenditure(as % of GDP) in Slovenia in 2002 to that in 2003?
Provide a short and direct response. 1.16. What is the ratio of the Expenditure(as % of GDP) in Thailand in 2002 to that in 2003?
Ensure brevity in your answer.  0.93. What is the ratio of the Expenditure(as % of GDP) of Czech Republic in 2002 to that in 2004?
Your answer should be very brief. 0.96. What is the ratio of the Expenditure(as % of GDP) in Malta in 2002 to that in 2004?
Your response must be concise. 0.49. What is the ratio of the Expenditure(as % of GDP) of Slovenia in 2002 to that in 2004?
Offer a very short reply. 1.05. What is the ratio of the Expenditure(as % of GDP) of Thailand in 2002 to that in 2004?
Your response must be concise. 0.96. What is the ratio of the Expenditure(as % of GDP) of Czech Republic in 2002 to that in 2005?
Your answer should be compact. 0.94. What is the ratio of the Expenditure(as % of GDP) of Malta in 2002 to that in 2005?
Provide a short and direct response. 0.46. What is the ratio of the Expenditure(as % of GDP) in Slovenia in 2002 to that in 2005?
Give a very brief answer. 1.02. What is the ratio of the Expenditure(as % of GDP) of Thailand in 2002 to that in 2005?
Give a very brief answer. 1.04. What is the ratio of the Expenditure(as % of GDP) of Czech Republic in 2002 to that in 2006?
Ensure brevity in your answer.  0.9. What is the ratio of the Expenditure(as % of GDP) in Malta in 2002 to that in 2006?
Ensure brevity in your answer.  0.42. What is the ratio of the Expenditure(as % of GDP) in Slovenia in 2002 to that in 2006?
Your answer should be very brief. 0.94. What is the ratio of the Expenditure(as % of GDP) in Thailand in 2002 to that in 2006?
Your response must be concise. 0.98. What is the ratio of the Expenditure(as % of GDP) of Czech Republic in 2002 to that in 2007?
Your answer should be compact. 0.85. What is the ratio of the Expenditure(as % of GDP) in Malta in 2002 to that in 2007?
Provide a succinct answer. 0.45. What is the ratio of the Expenditure(as % of GDP) in Slovenia in 2002 to that in 2007?
Give a very brief answer. 1.01. What is the ratio of the Expenditure(as % of GDP) in Thailand in 2002 to that in 2007?
Ensure brevity in your answer.  1.14. What is the ratio of the Expenditure(as % of GDP) in Czech Republic in 2002 to that in 2009?
Ensure brevity in your answer.  0.85. What is the ratio of the Expenditure(as % of GDP) of Malta in 2002 to that in 2009?
Your answer should be compact. 0.48. What is the ratio of the Expenditure(as % of GDP) in Slovenia in 2002 to that in 2009?
Offer a very short reply. 0.79. What is the ratio of the Expenditure(as % of GDP) of Czech Republic in 2002 to that in 2011?
Make the answer very short. 0.71. What is the ratio of the Expenditure(as % of GDP) in Malta in 2002 to that in 2011?
Keep it short and to the point. 0.36. What is the ratio of the Expenditure(as % of GDP) of Slovenia in 2002 to that in 2011?
Offer a terse response. 0.59. What is the ratio of the Expenditure(as % of GDP) in Thailand in 2002 to that in 2011?
Provide a succinct answer. 0.63. What is the ratio of the Expenditure(as % of GDP) in Malta in 2003 to that in 2004?
Provide a short and direct response. 0.48. What is the ratio of the Expenditure(as % of GDP) in Slovenia in 2003 to that in 2004?
Ensure brevity in your answer.  0.91. What is the ratio of the Expenditure(as % of GDP) in Thailand in 2003 to that in 2004?
Your answer should be compact. 1.03. What is the ratio of the Expenditure(as % of GDP) in Czech Republic in 2003 to that in 2005?
Provide a succinct answer. 0.98. What is the ratio of the Expenditure(as % of GDP) in Malta in 2003 to that in 2005?
Give a very brief answer. 0.45. What is the ratio of the Expenditure(as % of GDP) in Slovenia in 2003 to that in 2005?
Give a very brief answer. 0.88. What is the ratio of the Expenditure(as % of GDP) of Thailand in 2003 to that in 2005?
Keep it short and to the point. 1.11. What is the ratio of the Expenditure(as % of GDP) in Czech Republic in 2003 to that in 2006?
Make the answer very short. 0.93. What is the ratio of the Expenditure(as % of GDP) in Malta in 2003 to that in 2006?
Provide a succinct answer. 0.41. What is the ratio of the Expenditure(as % of GDP) in Slovenia in 2003 to that in 2006?
Offer a terse response. 0.81. What is the ratio of the Expenditure(as % of GDP) in Thailand in 2003 to that in 2006?
Your answer should be compact. 1.05. What is the ratio of the Expenditure(as % of GDP) of Czech Republic in 2003 to that in 2007?
Your response must be concise. 0.88. What is the ratio of the Expenditure(as % of GDP) of Malta in 2003 to that in 2007?
Make the answer very short. 0.44. What is the ratio of the Expenditure(as % of GDP) of Slovenia in 2003 to that in 2007?
Your response must be concise. 0.87. What is the ratio of the Expenditure(as % of GDP) of Thailand in 2003 to that in 2007?
Keep it short and to the point. 1.23. What is the ratio of the Expenditure(as % of GDP) in Czech Republic in 2003 to that in 2009?
Your response must be concise. 0.89. What is the ratio of the Expenditure(as % of GDP) of Malta in 2003 to that in 2009?
Keep it short and to the point. 0.46. What is the ratio of the Expenditure(as % of GDP) in Slovenia in 2003 to that in 2009?
Give a very brief answer. 0.69. What is the ratio of the Expenditure(as % of GDP) of Thailand in 2003 to that in 2009?
Offer a terse response. 1.05. What is the ratio of the Expenditure(as % of GDP) in Czech Republic in 2003 to that in 2011?
Your response must be concise. 0.74. What is the ratio of the Expenditure(as % of GDP) in Malta in 2003 to that in 2011?
Provide a succinct answer. 0.35. What is the ratio of the Expenditure(as % of GDP) of Slovenia in 2003 to that in 2011?
Offer a very short reply. 0.51. What is the ratio of the Expenditure(as % of GDP) of Thailand in 2003 to that in 2011?
Keep it short and to the point. 0.68. What is the ratio of the Expenditure(as % of GDP) in Czech Republic in 2004 to that in 2005?
Your response must be concise. 0.98. What is the ratio of the Expenditure(as % of GDP) of Malta in 2004 to that in 2005?
Your answer should be very brief. 0.94. What is the ratio of the Expenditure(as % of GDP) in Slovenia in 2004 to that in 2005?
Provide a succinct answer. 0.97. What is the ratio of the Expenditure(as % of GDP) in Thailand in 2004 to that in 2005?
Your answer should be very brief. 1.09. What is the ratio of the Expenditure(as % of GDP) of Czech Republic in 2004 to that in 2006?
Ensure brevity in your answer.  0.93. What is the ratio of the Expenditure(as % of GDP) of Malta in 2004 to that in 2006?
Your answer should be very brief. 0.86. What is the ratio of the Expenditure(as % of GDP) in Slovenia in 2004 to that in 2006?
Your answer should be compact. 0.89. What is the ratio of the Expenditure(as % of GDP) in Thailand in 2004 to that in 2006?
Provide a short and direct response. 1.02. What is the ratio of the Expenditure(as % of GDP) in Czech Republic in 2004 to that in 2007?
Give a very brief answer. 0.88. What is the ratio of the Expenditure(as % of GDP) of Malta in 2004 to that in 2007?
Offer a terse response. 0.91. What is the ratio of the Expenditure(as % of GDP) in Slovenia in 2004 to that in 2007?
Offer a terse response. 0.96. What is the ratio of the Expenditure(as % of GDP) of Thailand in 2004 to that in 2007?
Provide a succinct answer. 1.19. What is the ratio of the Expenditure(as % of GDP) in Czech Republic in 2004 to that in 2009?
Keep it short and to the point. 0.88. What is the ratio of the Expenditure(as % of GDP) in Malta in 2004 to that in 2009?
Your response must be concise. 0.97. What is the ratio of the Expenditure(as % of GDP) in Slovenia in 2004 to that in 2009?
Keep it short and to the point. 0.75. What is the ratio of the Expenditure(as % of GDP) of Thailand in 2004 to that in 2009?
Give a very brief answer. 1.02. What is the ratio of the Expenditure(as % of GDP) in Czech Republic in 2004 to that in 2011?
Provide a succinct answer. 0.74. What is the ratio of the Expenditure(as % of GDP) of Malta in 2004 to that in 2011?
Provide a short and direct response. 0.73. What is the ratio of the Expenditure(as % of GDP) in Slovenia in 2004 to that in 2011?
Offer a very short reply. 0.56. What is the ratio of the Expenditure(as % of GDP) in Thailand in 2004 to that in 2011?
Give a very brief answer. 0.66. What is the ratio of the Expenditure(as % of GDP) in Czech Republic in 2005 to that in 2006?
Your answer should be very brief. 0.95. What is the ratio of the Expenditure(as % of GDP) of Malta in 2005 to that in 2006?
Your answer should be compact. 0.92. What is the ratio of the Expenditure(as % of GDP) of Slovenia in 2005 to that in 2006?
Make the answer very short. 0.92. What is the ratio of the Expenditure(as % of GDP) in Thailand in 2005 to that in 2006?
Offer a very short reply. 0.94. What is the ratio of the Expenditure(as % of GDP) in Czech Republic in 2005 to that in 2007?
Your response must be concise. 0.9. What is the ratio of the Expenditure(as % of GDP) in Malta in 2005 to that in 2007?
Keep it short and to the point. 0.98. What is the ratio of the Expenditure(as % of GDP) in Slovenia in 2005 to that in 2007?
Your answer should be very brief. 0.99. What is the ratio of the Expenditure(as % of GDP) of Thailand in 2005 to that in 2007?
Make the answer very short. 1.1. What is the ratio of the Expenditure(as % of GDP) of Czech Republic in 2005 to that in 2009?
Make the answer very short. 0.9. What is the ratio of the Expenditure(as % of GDP) of Malta in 2005 to that in 2009?
Your answer should be compact. 1.04. What is the ratio of the Expenditure(as % of GDP) in Slovenia in 2005 to that in 2009?
Ensure brevity in your answer.  0.78. What is the ratio of the Expenditure(as % of GDP) in Thailand in 2005 to that in 2009?
Your answer should be compact. 0.94. What is the ratio of the Expenditure(as % of GDP) of Czech Republic in 2005 to that in 2011?
Provide a short and direct response. 0.75. What is the ratio of the Expenditure(as % of GDP) of Malta in 2005 to that in 2011?
Provide a succinct answer. 0.78. What is the ratio of the Expenditure(as % of GDP) of Slovenia in 2005 to that in 2011?
Your answer should be very brief. 0.58. What is the ratio of the Expenditure(as % of GDP) of Thailand in 2005 to that in 2011?
Make the answer very short. 0.61. What is the ratio of the Expenditure(as % of GDP) of Czech Republic in 2006 to that in 2007?
Provide a short and direct response. 0.95. What is the ratio of the Expenditure(as % of GDP) in Malta in 2006 to that in 2007?
Your response must be concise. 1.06. What is the ratio of the Expenditure(as % of GDP) in Slovenia in 2006 to that in 2007?
Keep it short and to the point. 1.08. What is the ratio of the Expenditure(as % of GDP) in Thailand in 2006 to that in 2007?
Provide a short and direct response. 1.17. What is the ratio of the Expenditure(as % of GDP) in Czech Republic in 2006 to that in 2009?
Offer a very short reply. 0.95. What is the ratio of the Expenditure(as % of GDP) in Malta in 2006 to that in 2009?
Keep it short and to the point. 1.13. What is the ratio of the Expenditure(as % of GDP) in Slovenia in 2006 to that in 2009?
Your answer should be very brief. 0.84. What is the ratio of the Expenditure(as % of GDP) in Thailand in 2006 to that in 2009?
Your answer should be compact. 0.99. What is the ratio of the Expenditure(as % of GDP) in Czech Republic in 2006 to that in 2011?
Provide a short and direct response. 0.79. What is the ratio of the Expenditure(as % of GDP) of Malta in 2006 to that in 2011?
Make the answer very short. 0.85. What is the ratio of the Expenditure(as % of GDP) in Slovenia in 2006 to that in 2011?
Give a very brief answer. 0.63. What is the ratio of the Expenditure(as % of GDP) of Thailand in 2006 to that in 2011?
Offer a very short reply. 0.64. What is the ratio of the Expenditure(as % of GDP) in Malta in 2007 to that in 2009?
Keep it short and to the point. 1.06. What is the ratio of the Expenditure(as % of GDP) of Slovenia in 2007 to that in 2009?
Make the answer very short. 0.78. What is the ratio of the Expenditure(as % of GDP) in Thailand in 2007 to that in 2009?
Offer a very short reply. 0.85. What is the ratio of the Expenditure(as % of GDP) in Czech Republic in 2007 to that in 2011?
Offer a very short reply. 0.84. What is the ratio of the Expenditure(as % of GDP) in Malta in 2007 to that in 2011?
Make the answer very short. 0.8. What is the ratio of the Expenditure(as % of GDP) in Slovenia in 2007 to that in 2011?
Your response must be concise. 0.59. What is the ratio of the Expenditure(as % of GDP) of Thailand in 2007 to that in 2011?
Keep it short and to the point. 0.55. What is the ratio of the Expenditure(as % of GDP) of Czech Republic in 2009 to that in 2011?
Offer a terse response. 0.83. What is the ratio of the Expenditure(as % of GDP) of Malta in 2009 to that in 2011?
Your answer should be compact. 0.76. What is the ratio of the Expenditure(as % of GDP) in Slovenia in 2009 to that in 2011?
Offer a very short reply. 0.75. What is the ratio of the Expenditure(as % of GDP) of Thailand in 2009 to that in 2011?
Give a very brief answer. 0.65. What is the difference between the highest and the second highest Expenditure(as % of GDP) in Czech Republic?
Offer a very short reply. 0.26. What is the difference between the highest and the second highest Expenditure(as % of GDP) of Malta?
Offer a very short reply. 0.1. What is the difference between the highest and the second highest Expenditure(as % of GDP) of Slovenia?
Provide a short and direct response. 0.61. What is the difference between the highest and the second highest Expenditure(as % of GDP) of Thailand?
Provide a succinct answer. 0.13. What is the difference between the highest and the lowest Expenditure(as % of GDP) in Czech Republic?
Your response must be concise. 0.46. What is the difference between the highest and the lowest Expenditure(as % of GDP) of Malta?
Offer a terse response. 0.47. What is the difference between the highest and the lowest Expenditure(as % of GDP) in Slovenia?
Provide a succinct answer. 1.18. What is the difference between the highest and the lowest Expenditure(as % of GDP) of Thailand?
Your response must be concise. 0.17. 